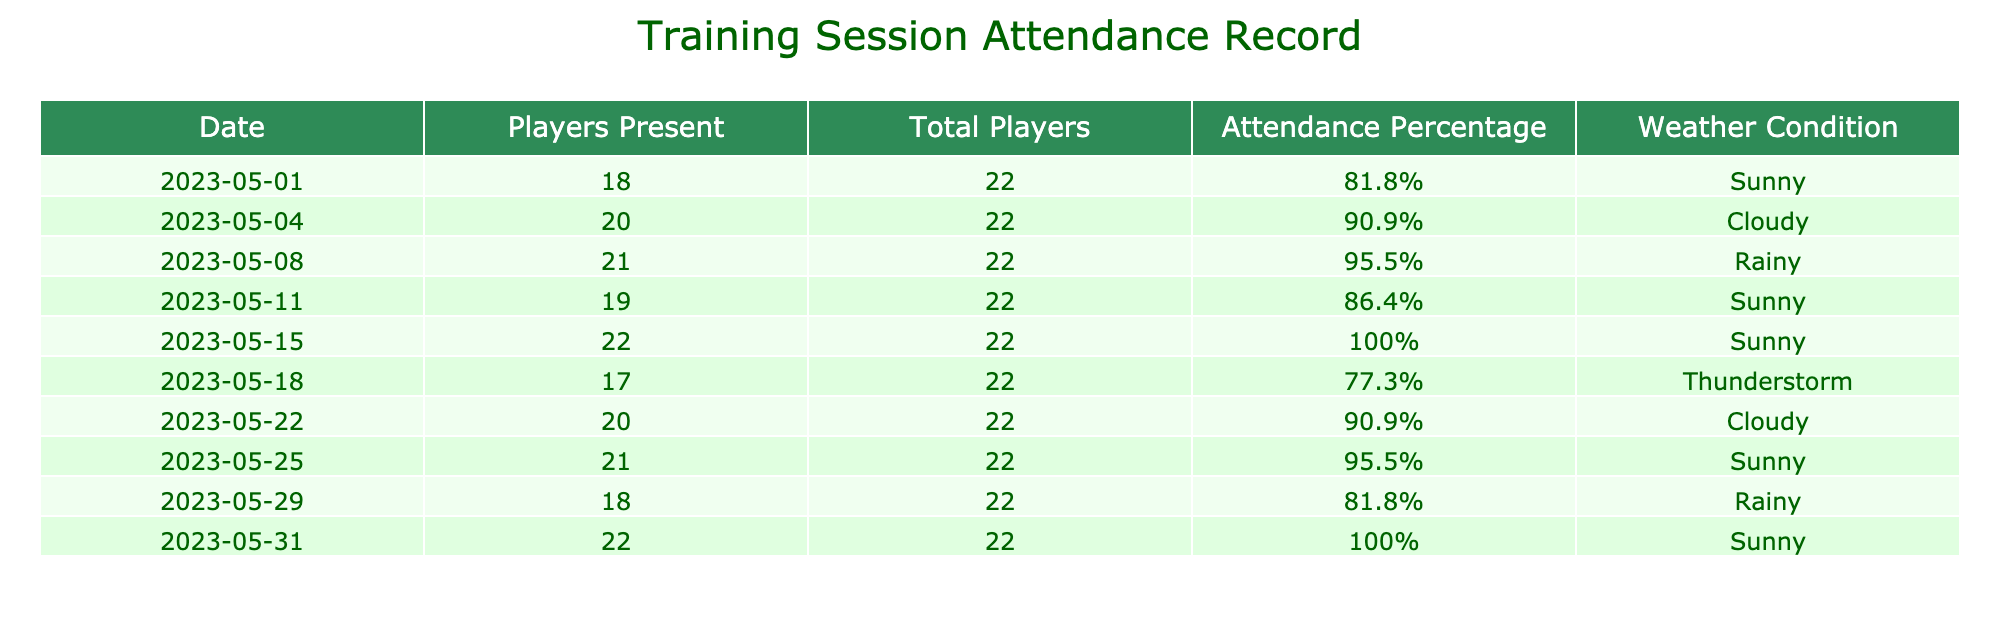What was the highest attendance percentage during the month? The highest attendance percentage can be found by looking at the "Attendance Percentage" column. Scanning through the values, we see two instances of 100%: on May 15 and May 31. Thus, the highest percentage is 100%.
Answer: 100% On which date did the least number of players attend training? To find the date with the least players present, we look at the "Players Present" column. The minimum value is 17 players, which occurred on May 18.
Answer: May 18 What was the average attendance percentage for the training sessions? To calculate the average, we sum all the attendance percentages: 81.8% + 90.9% + 95.5% + 86.4% + 100% + 77.3% + 90.9% + 95.5% + 81.8% + 100% = 900.2%. Since there are 10 sessions, we divide by 10: 900.2% / 10 = 90.02%.
Answer: 90.02% Was there a training session with 100% attendance? By checking the "Attendance Percentage" column, we see two instances of 100% attendance on May 15 and May 31, confirming that yes, there were training sessions with 100% attendance.
Answer: Yes How many training sessions had attendance percentages above 90%? To find this, we must count the sessions with percentages above 90%. The sessions on May 4, May 8, May 15, May 22, and May 25 meet this criterion. There are 5 such sessions.
Answer: 5 Which weather condition was most common on days with less than 80% attendance? We check the "Weather Condition" on the days where attendance is below 80%. These are May 18 (Thunderstorm) with 77.3% attendance. Since there is only one such instance, Thunderstorm is the most common weather condition for these days.
Answer: Thunderstorm What is the difference in player attendance between the best and worst performing session? The best performing session has 22 players present (100% attendance), while the worst performing session has 17 players (77.3% attendance). The difference is 22 - 17 = 5 players.
Answer: 5 Were there any training sessions held on rainy days? Checking the "Weather Condition" column, we find rainy days on May 8 and May 29, which confirms that there were indeed training sessions held on rainy days.
Answer: Yes 